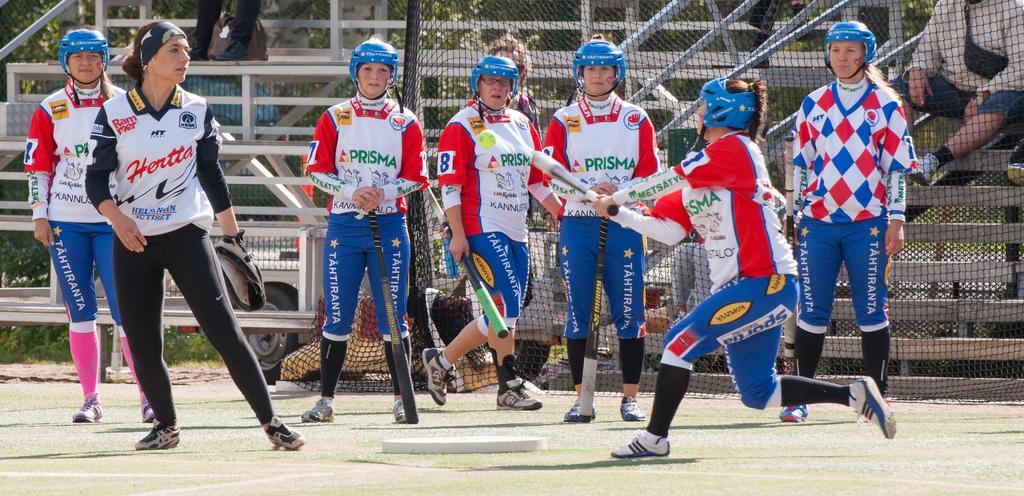Describe this image in one or two sentences. This image consists of women playing baseball. All are wearing blue color helmets. At the bottom, there is grass. In the background, there is a fencing along with steps. 